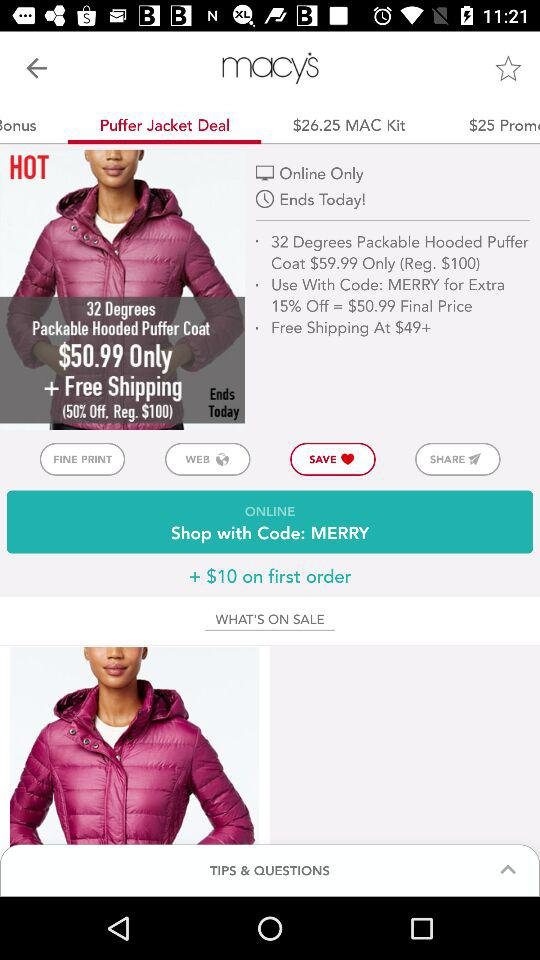What is the fine print?
When the provided information is insufficient, respond with <no answer>. <no answer> 